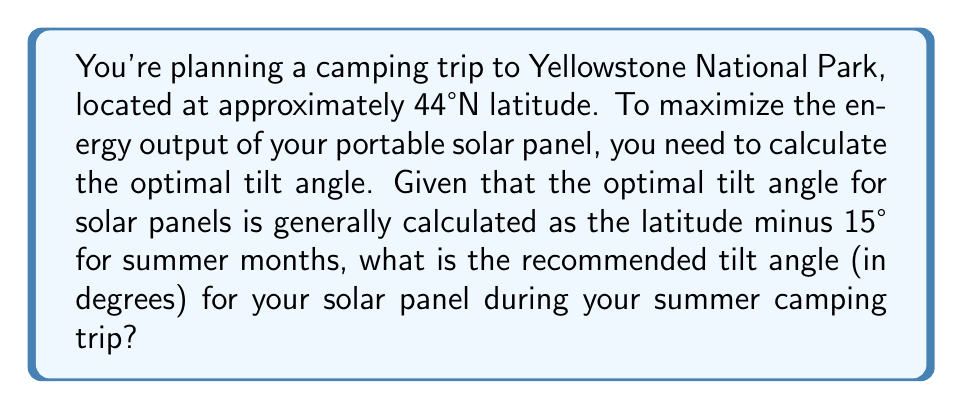Help me with this question. To solve this problem, we'll follow these steps:

1. Identify the given information:
   - Yellowstone National Park is at 44°N latitude
   - The optimal tilt angle formula for summer: $\text{Tilt Angle} = \text{Latitude} - 15°$

2. Apply the formula:
   $$\text{Tilt Angle} = 44° - 15°$$

3. Perform the subtraction:
   $$\text{Tilt Angle} = 29°$$

Therefore, the optimal tilt angle for your solar panel during your summer camping trip to Yellowstone National Park would be 29°.

This angle will help maximize the energy output of your solar panel by positioning it to receive the most direct sunlight during the summer months, ensuring a reliable power source for your camping equipment.
Answer: 29° 